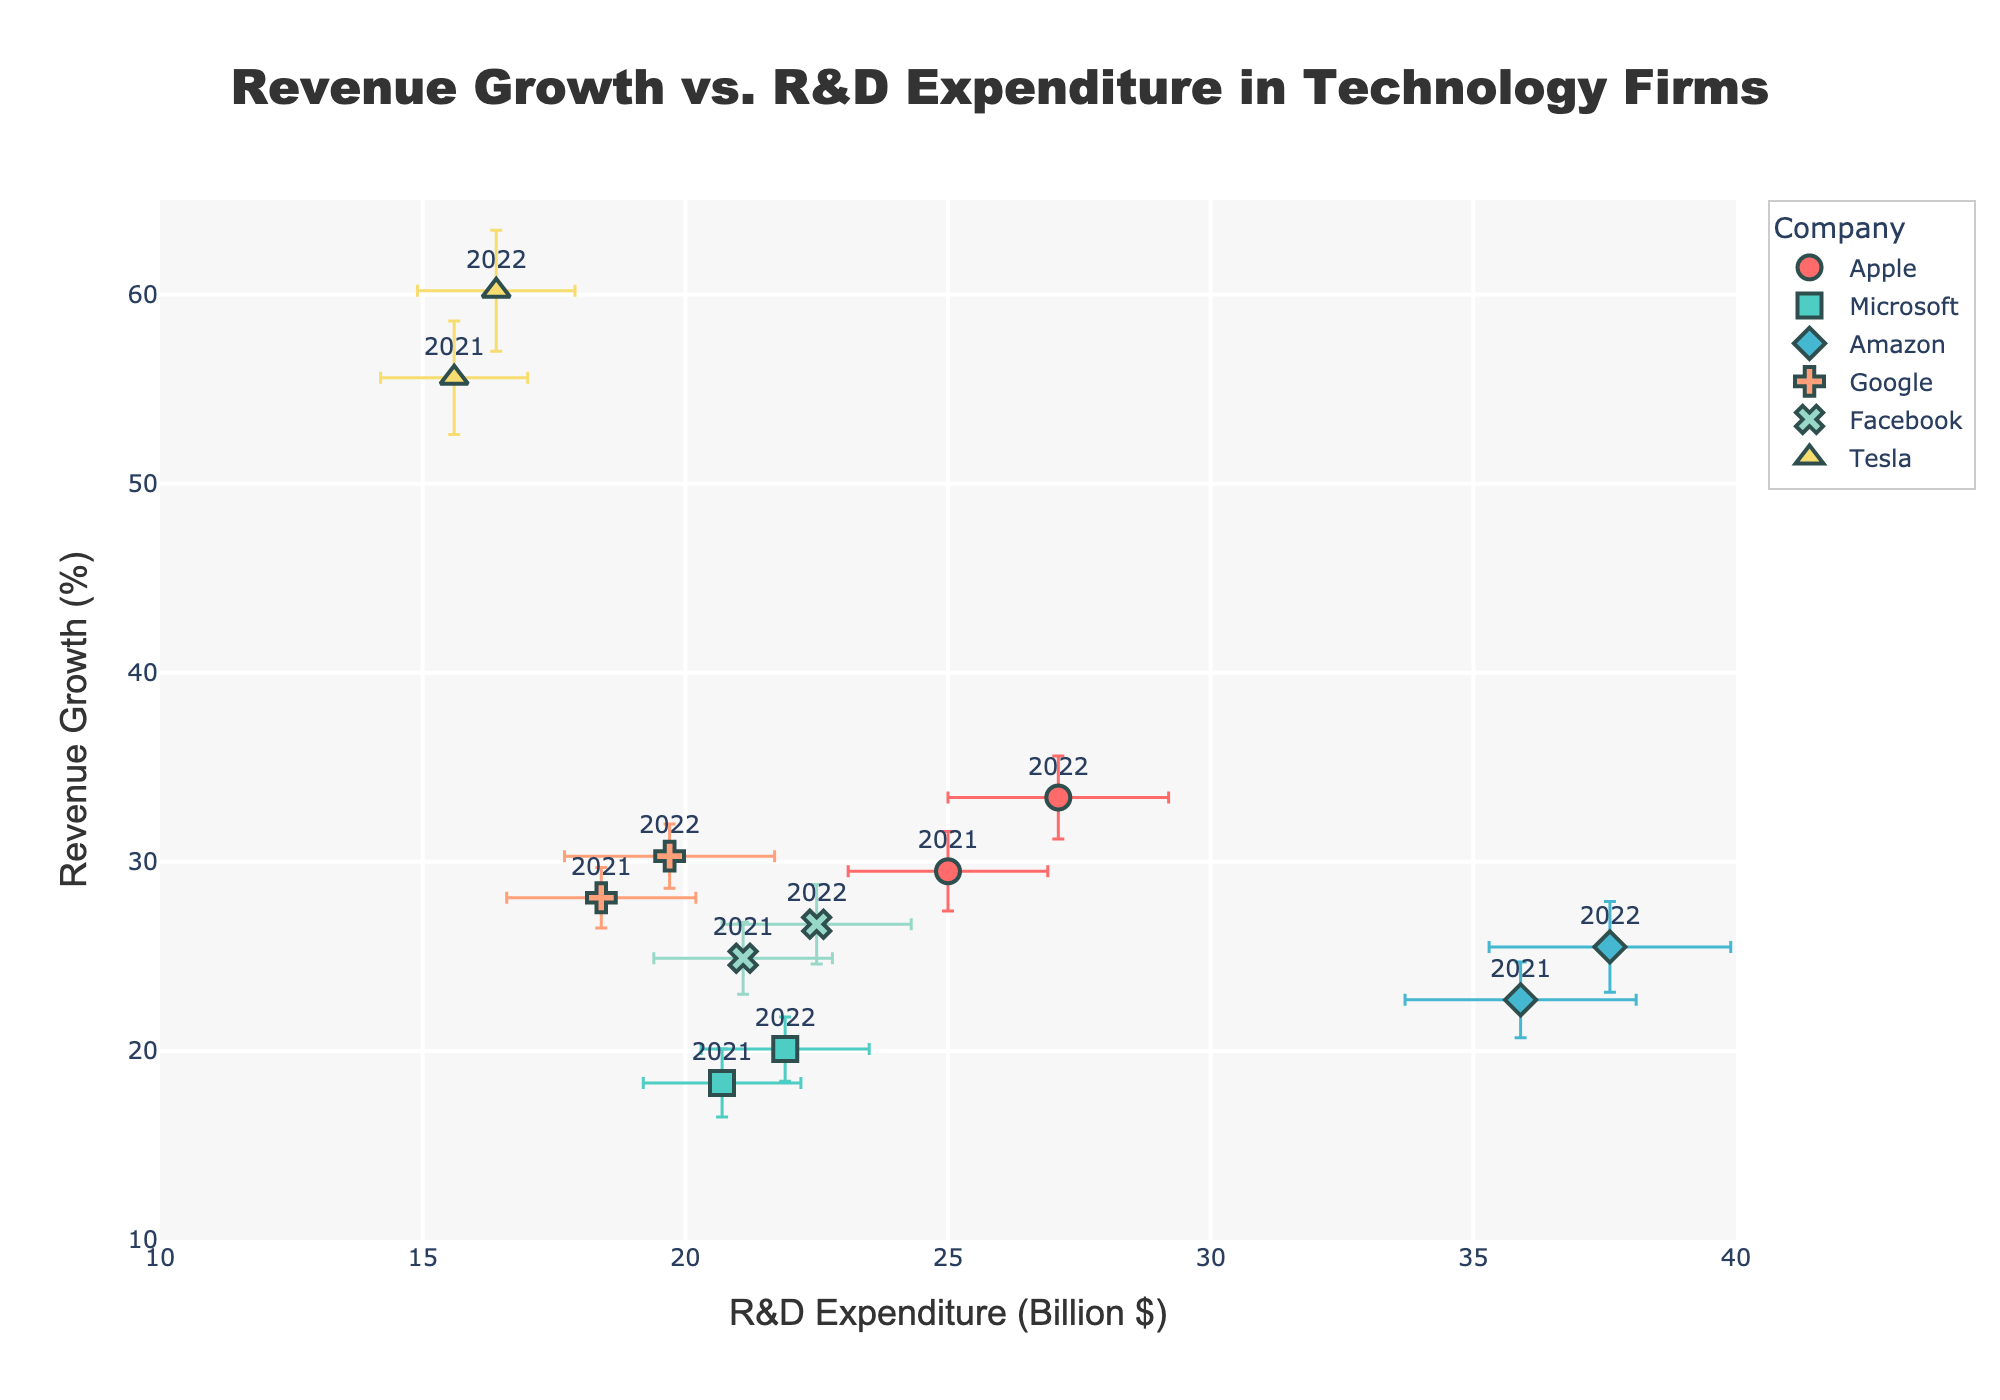What is the title of the plot? The title is prominently displayed at the top of the plot and reads "Revenue Growth vs. R&D Expenditure in Technology Firms."
Answer: Revenue Growth vs. R&D Expenditure in Technology Firms Which company has the highest revenue growth in 2022? We look at the markers labeled "2022" on the y-axis (Revenue Growth) and see that Tesla has the highest value.
Answer: Tesla What is the range of R&D expenditure shown on the x-axis? The x-axis ranges from 10 to 40 billion dollars, as seen on the axis range.
Answer: 10 to 40 billion dollars How much did Apple’s revenue growth increase from 2021 to 2022? Apple’s revenue growth in 2021 is 29.5%, and in 2022 it is 33.4%. The increase is calculated as 33.4% - 29.5%.
Answer: 3.9% Compare Amazon and Facebook’s R&D expenditure in 2022. Which one is higher and by how much? Amazon’s R&D expenditure in 2022 is 37.6 billion dollars, while Facebook’s is 22.5 billion dollars. The difference is 37.6 - 22.5.
Answer: Amazon, by 15.1 billion dollars Which company’s data points have the largest standard deviation in revenue growth? Tesla’s data points have error bars that are the longest on the y-axis, indicating the largest standard deviation in revenue growth.
Answer: Tesla What is the average revenue growth of the companies in 2022? Adding the revenue growth of all companies in 2022 (33.4 + 20.1 + 25.5 + 30.3 + 26.7 + 60.2) gives 196.2. Dividing by 6 companies gives an average.
Answer: 32.7% Between which years does Google show the largest increase in R&D expenditure? Google’s R&D expenditure increases from 18.4 billion dollars in 2021 to 19.7 billion dollars in 2022. There is no other year provided for comparison.
Answer: 2021 to 2022 Which company has the lowest R&D expenditure in 2021, and what is the value? Tesla has the lowest R&D expenditure in 2021 at 15.6 billion dollars.
Answer: Tesla, 15.6 billion dollars What is the trend in Microsoft’s revenue growth from 2021 to 2022? Microsoft’s revenue growth increases from 18.3% in 2021 to 20.1% in 2022, showing an upward trend.
Answer: Increasing 